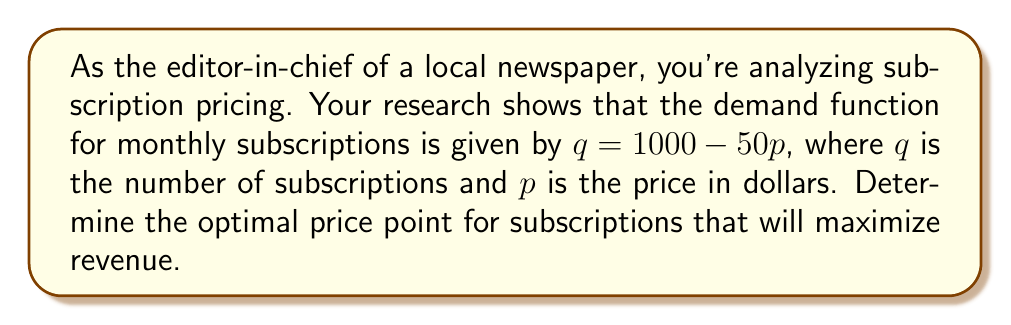What is the answer to this math problem? To find the optimal price point, we need to maximize the revenue function. Let's approach this step-by-step:

1) First, let's define the revenue function:
   $R = pq = p(1000 - 50p) = 1000p - 50p^2$

2) To find the maximum revenue, we need to find the derivative of R with respect to p and set it equal to zero:
   $$\frac{dR}{dp} = 1000 - 100p$$

3) Set this equal to zero and solve for p:
   $$1000 - 100p = 0$$
   $$100p = 1000$$
   $$p = 10$$

4) To confirm this is a maximum (not a minimum), we can check the second derivative:
   $$\frac{d^2R}{dp^2} = -100$$
   Since this is negative, we confirm that $p = 10$ gives a maximum.

5) At $p = 10$, the quantity of subscriptions would be:
   $q = 1000 - 50(10) = 500$

6) Therefore, the optimal price point is $10, which would result in 500 subscriptions.

7) We can verify the revenue at this point:
   $R = 10 * 500 = 5000$

This is indeed the maximum revenue achievable given the demand function.
Answer: $10 per subscription 